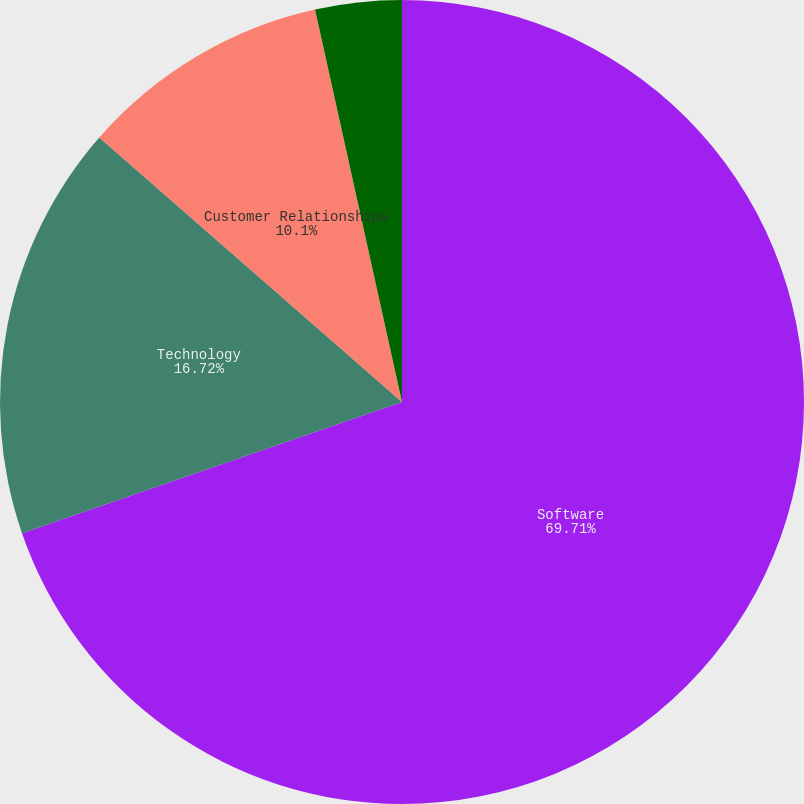<chart> <loc_0><loc_0><loc_500><loc_500><pie_chart><fcel>Software<fcel>Technology<fcel>Customer Relationships<fcel>Other<nl><fcel>69.71%<fcel>16.72%<fcel>10.1%<fcel>3.47%<nl></chart> 